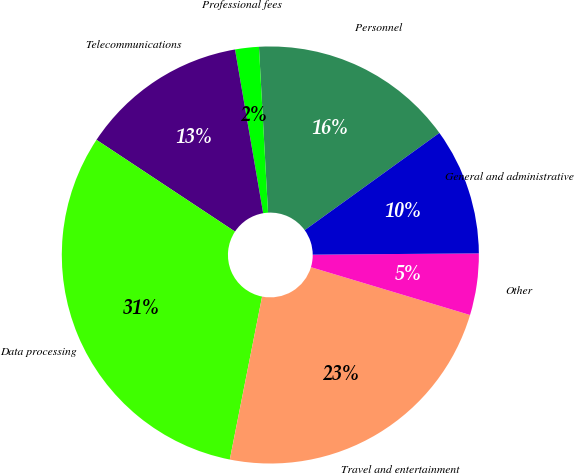<chart> <loc_0><loc_0><loc_500><loc_500><pie_chart><fcel>Personnel<fcel>Professional fees<fcel>Telecommunications<fcel>Data processing<fcel>Travel and entertainment<fcel>Other<fcel>General and administrative<nl><fcel>15.92%<fcel>1.84%<fcel>12.98%<fcel>31.2%<fcel>23.47%<fcel>4.77%<fcel>9.83%<nl></chart> 